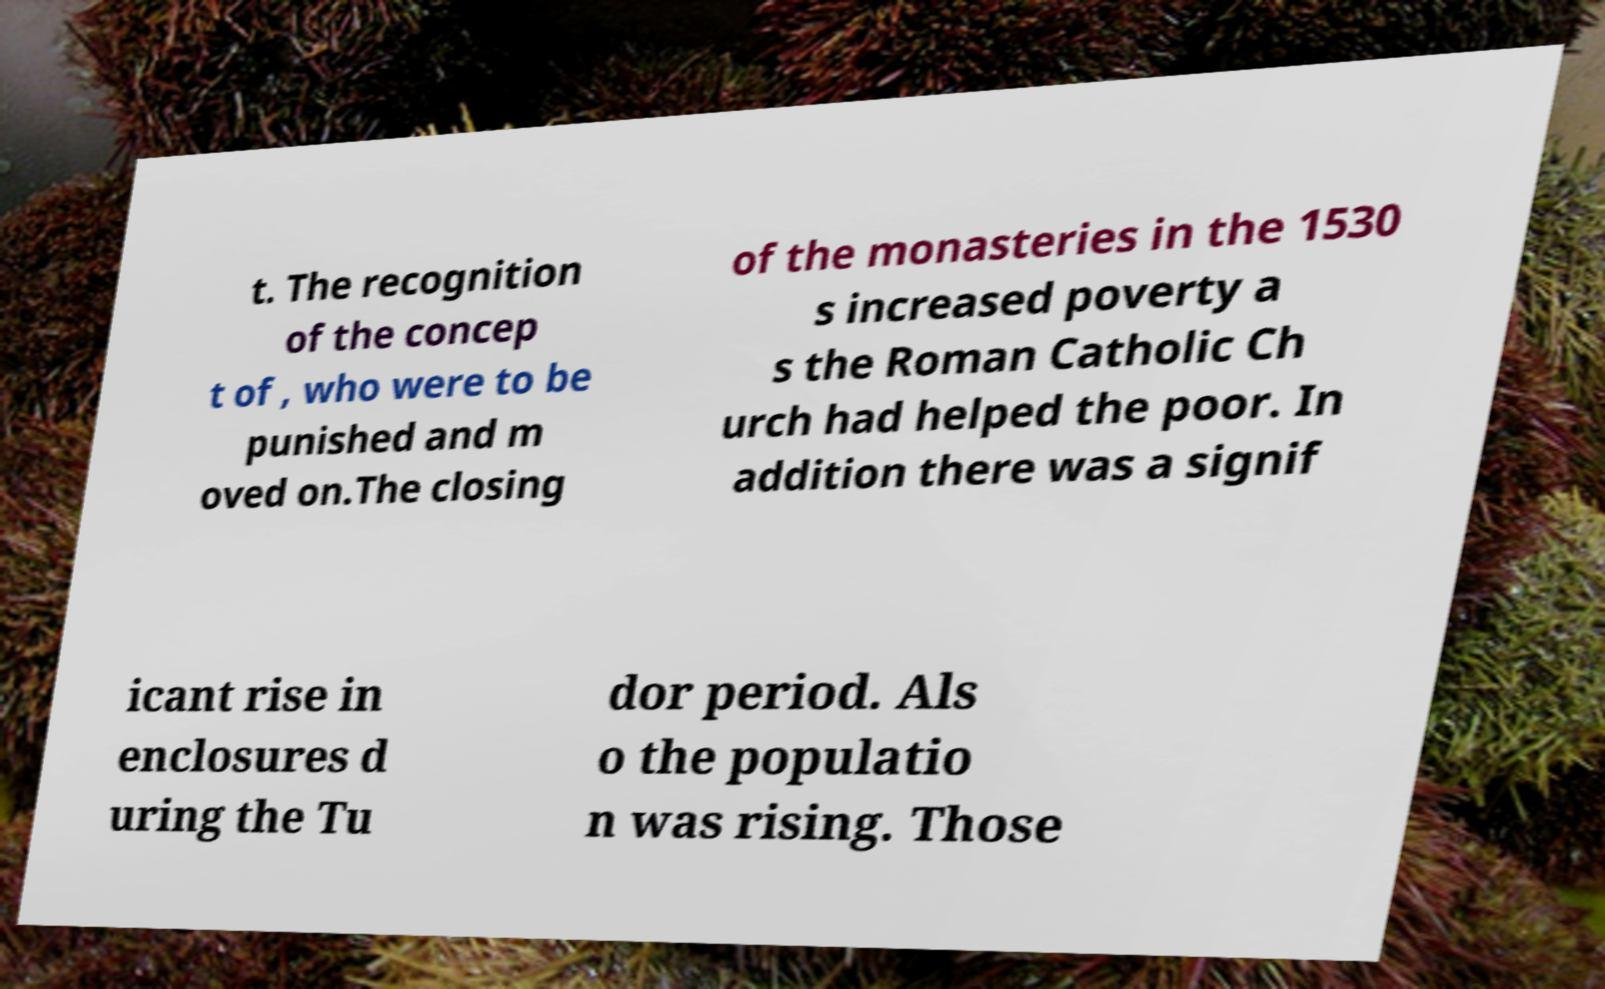There's text embedded in this image that I need extracted. Can you transcribe it verbatim? t. The recognition of the concep t of , who were to be punished and m oved on.The closing of the monasteries in the 1530 s increased poverty a s the Roman Catholic Ch urch had helped the poor. In addition there was a signif icant rise in enclosures d uring the Tu dor period. Als o the populatio n was rising. Those 